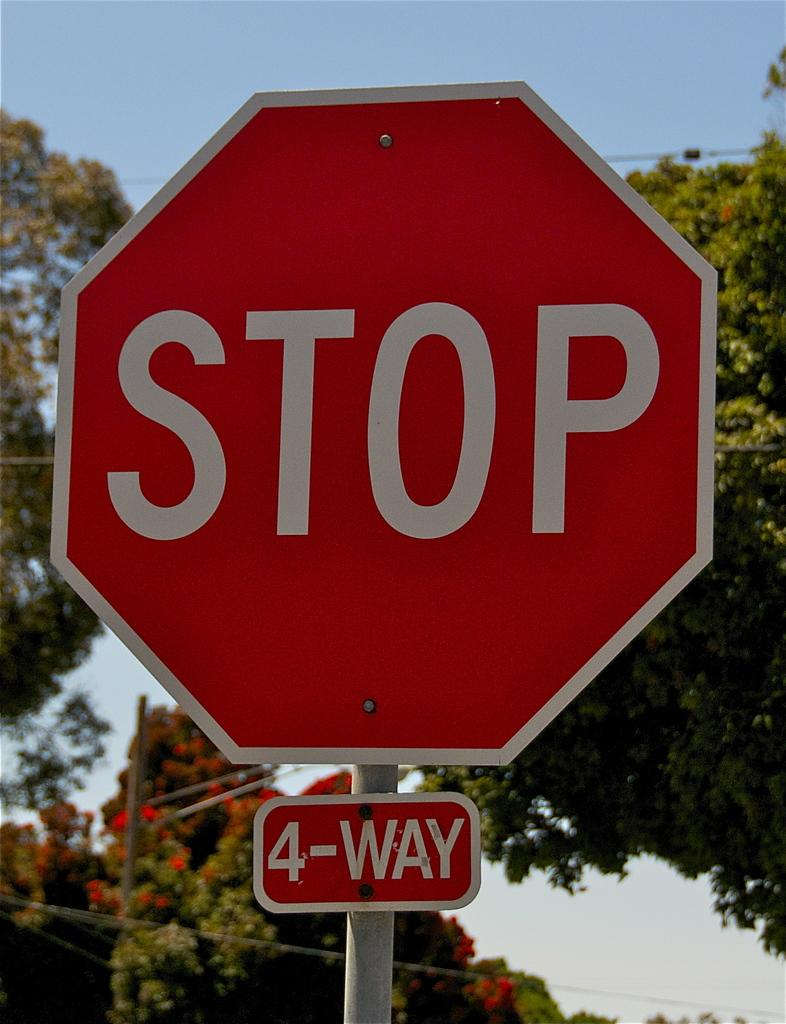Provide a one-sentence caption for the provided image. a 4-way stop sign in outdoor street corner. 